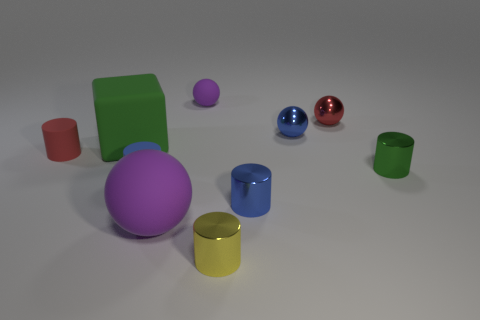Subtract all cyan spheres. How many blue cylinders are left? 2 Subtract all small matte spheres. How many spheres are left? 3 Subtract all cubes. How many objects are left? 9 Subtract 3 cylinders. How many cylinders are left? 2 Subtract all green cylinders. How many cylinders are left? 4 Subtract all tiny purple rubber things. Subtract all matte blocks. How many objects are left? 8 Add 6 blue shiny objects. How many blue shiny objects are left? 8 Add 2 small green rubber things. How many small green rubber things exist? 2 Subtract 0 brown cubes. How many objects are left? 10 Subtract all red balls. Subtract all red blocks. How many balls are left? 3 